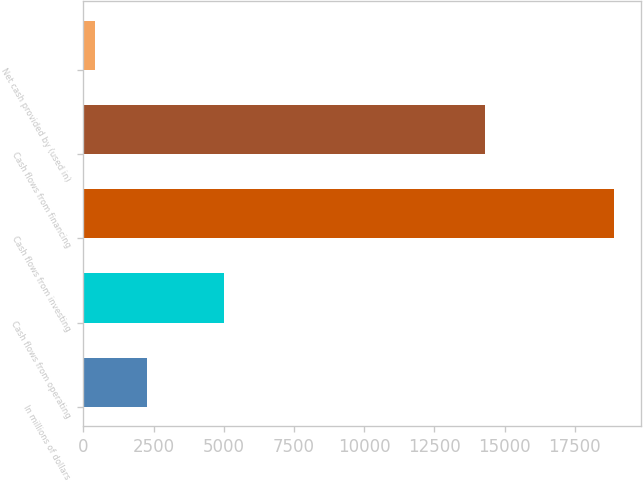Convert chart to OTSL. <chart><loc_0><loc_0><loc_500><loc_500><bar_chart><fcel>In millions of dollars<fcel>Cash flows from operating<fcel>Cash flows from investing<fcel>Cash flows from financing<fcel>Net cash provided by (used in)<nl><fcel>2246.9<fcel>5006<fcel>18896<fcel>14287<fcel>397<nl></chart> 